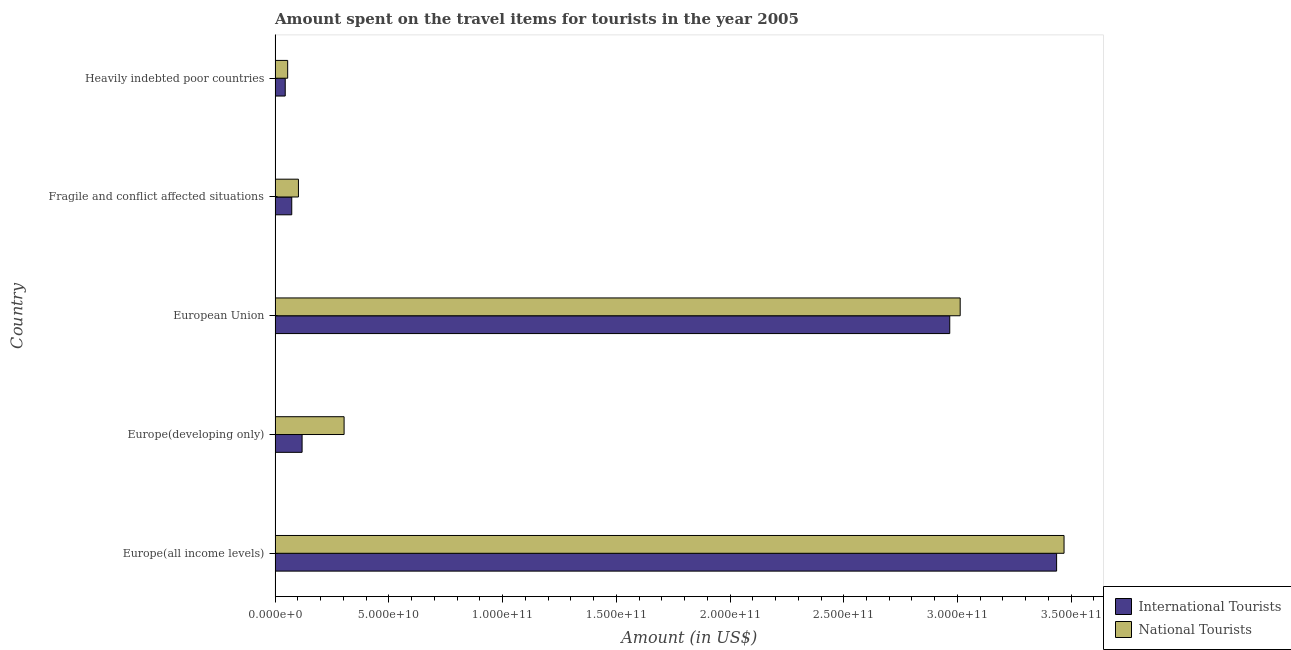How many groups of bars are there?
Provide a succinct answer. 5. Are the number of bars per tick equal to the number of legend labels?
Ensure brevity in your answer.  Yes. Are the number of bars on each tick of the Y-axis equal?
Your answer should be very brief. Yes. How many bars are there on the 4th tick from the top?
Provide a short and direct response. 2. How many bars are there on the 5th tick from the bottom?
Keep it short and to the point. 2. What is the label of the 4th group of bars from the top?
Make the answer very short. Europe(developing only). In how many cases, is the number of bars for a given country not equal to the number of legend labels?
Make the answer very short. 0. What is the amount spent on travel items of national tourists in Fragile and conflict affected situations?
Offer a terse response. 1.03e+1. Across all countries, what is the maximum amount spent on travel items of international tourists?
Keep it short and to the point. 3.44e+11. Across all countries, what is the minimum amount spent on travel items of international tourists?
Offer a terse response. 4.46e+09. In which country was the amount spent on travel items of national tourists maximum?
Provide a short and direct response. Europe(all income levels). In which country was the amount spent on travel items of international tourists minimum?
Your answer should be very brief. Heavily indebted poor countries. What is the total amount spent on travel items of international tourists in the graph?
Offer a very short reply. 6.64e+11. What is the difference between the amount spent on travel items of national tourists in Fragile and conflict affected situations and that in Heavily indebted poor countries?
Your answer should be compact. 4.73e+09. What is the difference between the amount spent on travel items of national tourists in Europe(developing only) and the amount spent on travel items of international tourists in European Union?
Your answer should be very brief. -2.66e+11. What is the average amount spent on travel items of international tourists per country?
Your answer should be very brief. 1.33e+11. What is the difference between the amount spent on travel items of international tourists and amount spent on travel items of national tourists in Fragile and conflict affected situations?
Offer a very short reply. -2.94e+09. What is the ratio of the amount spent on travel items of international tourists in Europe(developing only) to that in European Union?
Offer a terse response. 0.04. Is the difference between the amount spent on travel items of national tourists in Europe(developing only) and Fragile and conflict affected situations greater than the difference between the amount spent on travel items of international tourists in Europe(developing only) and Fragile and conflict affected situations?
Keep it short and to the point. Yes. What is the difference between the highest and the second highest amount spent on travel items of international tourists?
Ensure brevity in your answer.  4.70e+1. What is the difference between the highest and the lowest amount spent on travel items of national tourists?
Provide a short and direct response. 3.41e+11. In how many countries, is the amount spent on travel items of national tourists greater than the average amount spent on travel items of national tourists taken over all countries?
Your response must be concise. 2. Is the sum of the amount spent on travel items of international tourists in Europe(all income levels) and Fragile and conflict affected situations greater than the maximum amount spent on travel items of national tourists across all countries?
Your answer should be very brief. Yes. What does the 1st bar from the top in Europe(all income levels) represents?
Give a very brief answer. National Tourists. What does the 1st bar from the bottom in Heavily indebted poor countries represents?
Make the answer very short. International Tourists. How many bars are there?
Offer a terse response. 10. How many countries are there in the graph?
Your response must be concise. 5. Are the values on the major ticks of X-axis written in scientific E-notation?
Give a very brief answer. Yes. Does the graph contain any zero values?
Give a very brief answer. No. Does the graph contain grids?
Offer a very short reply. No. What is the title of the graph?
Offer a terse response. Amount spent on the travel items for tourists in the year 2005. What is the label or title of the X-axis?
Provide a succinct answer. Amount (in US$). What is the label or title of the Y-axis?
Your answer should be compact. Country. What is the Amount (in US$) of International Tourists in Europe(all income levels)?
Your answer should be compact. 3.44e+11. What is the Amount (in US$) in National Tourists in Europe(all income levels)?
Provide a succinct answer. 3.47e+11. What is the Amount (in US$) of International Tourists in Europe(developing only)?
Ensure brevity in your answer.  1.19e+1. What is the Amount (in US$) in National Tourists in Europe(developing only)?
Your response must be concise. 3.03e+1. What is the Amount (in US$) in International Tourists in European Union?
Provide a succinct answer. 2.97e+11. What is the Amount (in US$) of National Tourists in European Union?
Your answer should be compact. 3.01e+11. What is the Amount (in US$) of International Tourists in Fragile and conflict affected situations?
Your response must be concise. 7.33e+09. What is the Amount (in US$) in National Tourists in Fragile and conflict affected situations?
Your response must be concise. 1.03e+1. What is the Amount (in US$) in International Tourists in Heavily indebted poor countries?
Your response must be concise. 4.46e+09. What is the Amount (in US$) of National Tourists in Heavily indebted poor countries?
Your answer should be very brief. 5.54e+09. Across all countries, what is the maximum Amount (in US$) of International Tourists?
Keep it short and to the point. 3.44e+11. Across all countries, what is the maximum Amount (in US$) in National Tourists?
Ensure brevity in your answer.  3.47e+11. Across all countries, what is the minimum Amount (in US$) in International Tourists?
Offer a very short reply. 4.46e+09. Across all countries, what is the minimum Amount (in US$) of National Tourists?
Ensure brevity in your answer.  5.54e+09. What is the total Amount (in US$) of International Tourists in the graph?
Your response must be concise. 6.64e+11. What is the total Amount (in US$) of National Tourists in the graph?
Offer a terse response. 6.94e+11. What is the difference between the Amount (in US$) in International Tourists in Europe(all income levels) and that in Europe(developing only)?
Provide a succinct answer. 3.32e+11. What is the difference between the Amount (in US$) in National Tourists in Europe(all income levels) and that in Europe(developing only)?
Offer a very short reply. 3.17e+11. What is the difference between the Amount (in US$) in International Tourists in Europe(all income levels) and that in European Union?
Ensure brevity in your answer.  4.70e+1. What is the difference between the Amount (in US$) in National Tourists in Europe(all income levels) and that in European Union?
Provide a short and direct response. 4.57e+1. What is the difference between the Amount (in US$) in International Tourists in Europe(all income levels) and that in Fragile and conflict affected situations?
Offer a very short reply. 3.36e+11. What is the difference between the Amount (in US$) in National Tourists in Europe(all income levels) and that in Fragile and conflict affected situations?
Ensure brevity in your answer.  3.37e+11. What is the difference between the Amount (in US$) of International Tourists in Europe(all income levels) and that in Heavily indebted poor countries?
Make the answer very short. 3.39e+11. What is the difference between the Amount (in US$) in National Tourists in Europe(all income levels) and that in Heavily indebted poor countries?
Offer a very short reply. 3.41e+11. What is the difference between the Amount (in US$) in International Tourists in Europe(developing only) and that in European Union?
Offer a terse response. -2.85e+11. What is the difference between the Amount (in US$) in National Tourists in Europe(developing only) and that in European Union?
Ensure brevity in your answer.  -2.71e+11. What is the difference between the Amount (in US$) in International Tourists in Europe(developing only) and that in Fragile and conflict affected situations?
Your response must be concise. 4.55e+09. What is the difference between the Amount (in US$) in National Tourists in Europe(developing only) and that in Fragile and conflict affected situations?
Offer a very short reply. 2.01e+1. What is the difference between the Amount (in US$) of International Tourists in Europe(developing only) and that in Heavily indebted poor countries?
Make the answer very short. 7.42e+09. What is the difference between the Amount (in US$) in National Tourists in Europe(developing only) and that in Heavily indebted poor countries?
Keep it short and to the point. 2.48e+1. What is the difference between the Amount (in US$) in International Tourists in European Union and that in Fragile and conflict affected situations?
Your response must be concise. 2.89e+11. What is the difference between the Amount (in US$) in National Tourists in European Union and that in Fragile and conflict affected situations?
Keep it short and to the point. 2.91e+11. What is the difference between the Amount (in US$) in International Tourists in European Union and that in Heavily indebted poor countries?
Provide a succinct answer. 2.92e+11. What is the difference between the Amount (in US$) of National Tourists in European Union and that in Heavily indebted poor countries?
Offer a terse response. 2.96e+11. What is the difference between the Amount (in US$) in International Tourists in Fragile and conflict affected situations and that in Heavily indebted poor countries?
Your response must be concise. 2.87e+09. What is the difference between the Amount (in US$) in National Tourists in Fragile and conflict affected situations and that in Heavily indebted poor countries?
Ensure brevity in your answer.  4.73e+09. What is the difference between the Amount (in US$) of International Tourists in Europe(all income levels) and the Amount (in US$) of National Tourists in Europe(developing only)?
Your answer should be compact. 3.13e+11. What is the difference between the Amount (in US$) in International Tourists in Europe(all income levels) and the Amount (in US$) in National Tourists in European Union?
Keep it short and to the point. 4.24e+1. What is the difference between the Amount (in US$) of International Tourists in Europe(all income levels) and the Amount (in US$) of National Tourists in Fragile and conflict affected situations?
Ensure brevity in your answer.  3.33e+11. What is the difference between the Amount (in US$) of International Tourists in Europe(all income levels) and the Amount (in US$) of National Tourists in Heavily indebted poor countries?
Ensure brevity in your answer.  3.38e+11. What is the difference between the Amount (in US$) of International Tourists in Europe(developing only) and the Amount (in US$) of National Tourists in European Union?
Your response must be concise. -2.89e+11. What is the difference between the Amount (in US$) in International Tourists in Europe(developing only) and the Amount (in US$) in National Tourists in Fragile and conflict affected situations?
Provide a succinct answer. 1.61e+09. What is the difference between the Amount (in US$) of International Tourists in Europe(developing only) and the Amount (in US$) of National Tourists in Heavily indebted poor countries?
Your answer should be compact. 6.34e+09. What is the difference between the Amount (in US$) in International Tourists in European Union and the Amount (in US$) in National Tourists in Fragile and conflict affected situations?
Ensure brevity in your answer.  2.86e+11. What is the difference between the Amount (in US$) in International Tourists in European Union and the Amount (in US$) in National Tourists in Heavily indebted poor countries?
Your response must be concise. 2.91e+11. What is the difference between the Amount (in US$) of International Tourists in Fragile and conflict affected situations and the Amount (in US$) of National Tourists in Heavily indebted poor countries?
Your answer should be very brief. 1.79e+09. What is the average Amount (in US$) in International Tourists per country?
Ensure brevity in your answer.  1.33e+11. What is the average Amount (in US$) in National Tourists per country?
Give a very brief answer. 1.39e+11. What is the difference between the Amount (in US$) of International Tourists and Amount (in US$) of National Tourists in Europe(all income levels)?
Ensure brevity in your answer.  -3.27e+09. What is the difference between the Amount (in US$) of International Tourists and Amount (in US$) of National Tourists in Europe(developing only)?
Give a very brief answer. -1.85e+1. What is the difference between the Amount (in US$) in International Tourists and Amount (in US$) in National Tourists in European Union?
Your answer should be compact. -4.59e+09. What is the difference between the Amount (in US$) of International Tourists and Amount (in US$) of National Tourists in Fragile and conflict affected situations?
Provide a succinct answer. -2.94e+09. What is the difference between the Amount (in US$) of International Tourists and Amount (in US$) of National Tourists in Heavily indebted poor countries?
Offer a terse response. -1.08e+09. What is the ratio of the Amount (in US$) of International Tourists in Europe(all income levels) to that in Europe(developing only)?
Offer a terse response. 28.93. What is the ratio of the Amount (in US$) of National Tourists in Europe(all income levels) to that in Europe(developing only)?
Your response must be concise. 11.43. What is the ratio of the Amount (in US$) of International Tourists in Europe(all income levels) to that in European Union?
Provide a short and direct response. 1.16. What is the ratio of the Amount (in US$) in National Tourists in Europe(all income levels) to that in European Union?
Your response must be concise. 1.15. What is the ratio of the Amount (in US$) in International Tourists in Europe(all income levels) to that in Fragile and conflict affected situations?
Offer a very short reply. 46.88. What is the ratio of the Amount (in US$) of National Tourists in Europe(all income levels) to that in Fragile and conflict affected situations?
Give a very brief answer. 33.78. What is the ratio of the Amount (in US$) in International Tourists in Europe(all income levels) to that in Heavily indebted poor countries?
Your answer should be very brief. 77.01. What is the ratio of the Amount (in US$) in National Tourists in Europe(all income levels) to that in Heavily indebted poor countries?
Your answer should be compact. 62.64. What is the ratio of the Amount (in US$) of National Tourists in Europe(developing only) to that in European Union?
Provide a succinct answer. 0.1. What is the ratio of the Amount (in US$) of International Tourists in Europe(developing only) to that in Fragile and conflict affected situations?
Provide a succinct answer. 1.62. What is the ratio of the Amount (in US$) of National Tourists in Europe(developing only) to that in Fragile and conflict affected situations?
Provide a succinct answer. 2.96. What is the ratio of the Amount (in US$) of International Tourists in Europe(developing only) to that in Heavily indebted poor countries?
Your answer should be compact. 2.66. What is the ratio of the Amount (in US$) of National Tourists in Europe(developing only) to that in Heavily indebted poor countries?
Provide a succinct answer. 5.48. What is the ratio of the Amount (in US$) in International Tourists in European Union to that in Fragile and conflict affected situations?
Ensure brevity in your answer.  40.47. What is the ratio of the Amount (in US$) of National Tourists in European Union to that in Fragile and conflict affected situations?
Keep it short and to the point. 29.33. What is the ratio of the Amount (in US$) of International Tourists in European Union to that in Heavily indebted poor countries?
Your answer should be very brief. 66.48. What is the ratio of the Amount (in US$) in National Tourists in European Union to that in Heavily indebted poor countries?
Ensure brevity in your answer.  54.4. What is the ratio of the Amount (in US$) in International Tourists in Fragile and conflict affected situations to that in Heavily indebted poor countries?
Keep it short and to the point. 1.64. What is the ratio of the Amount (in US$) in National Tourists in Fragile and conflict affected situations to that in Heavily indebted poor countries?
Keep it short and to the point. 1.85. What is the difference between the highest and the second highest Amount (in US$) of International Tourists?
Provide a short and direct response. 4.70e+1. What is the difference between the highest and the second highest Amount (in US$) in National Tourists?
Your answer should be very brief. 4.57e+1. What is the difference between the highest and the lowest Amount (in US$) of International Tourists?
Offer a very short reply. 3.39e+11. What is the difference between the highest and the lowest Amount (in US$) of National Tourists?
Offer a terse response. 3.41e+11. 